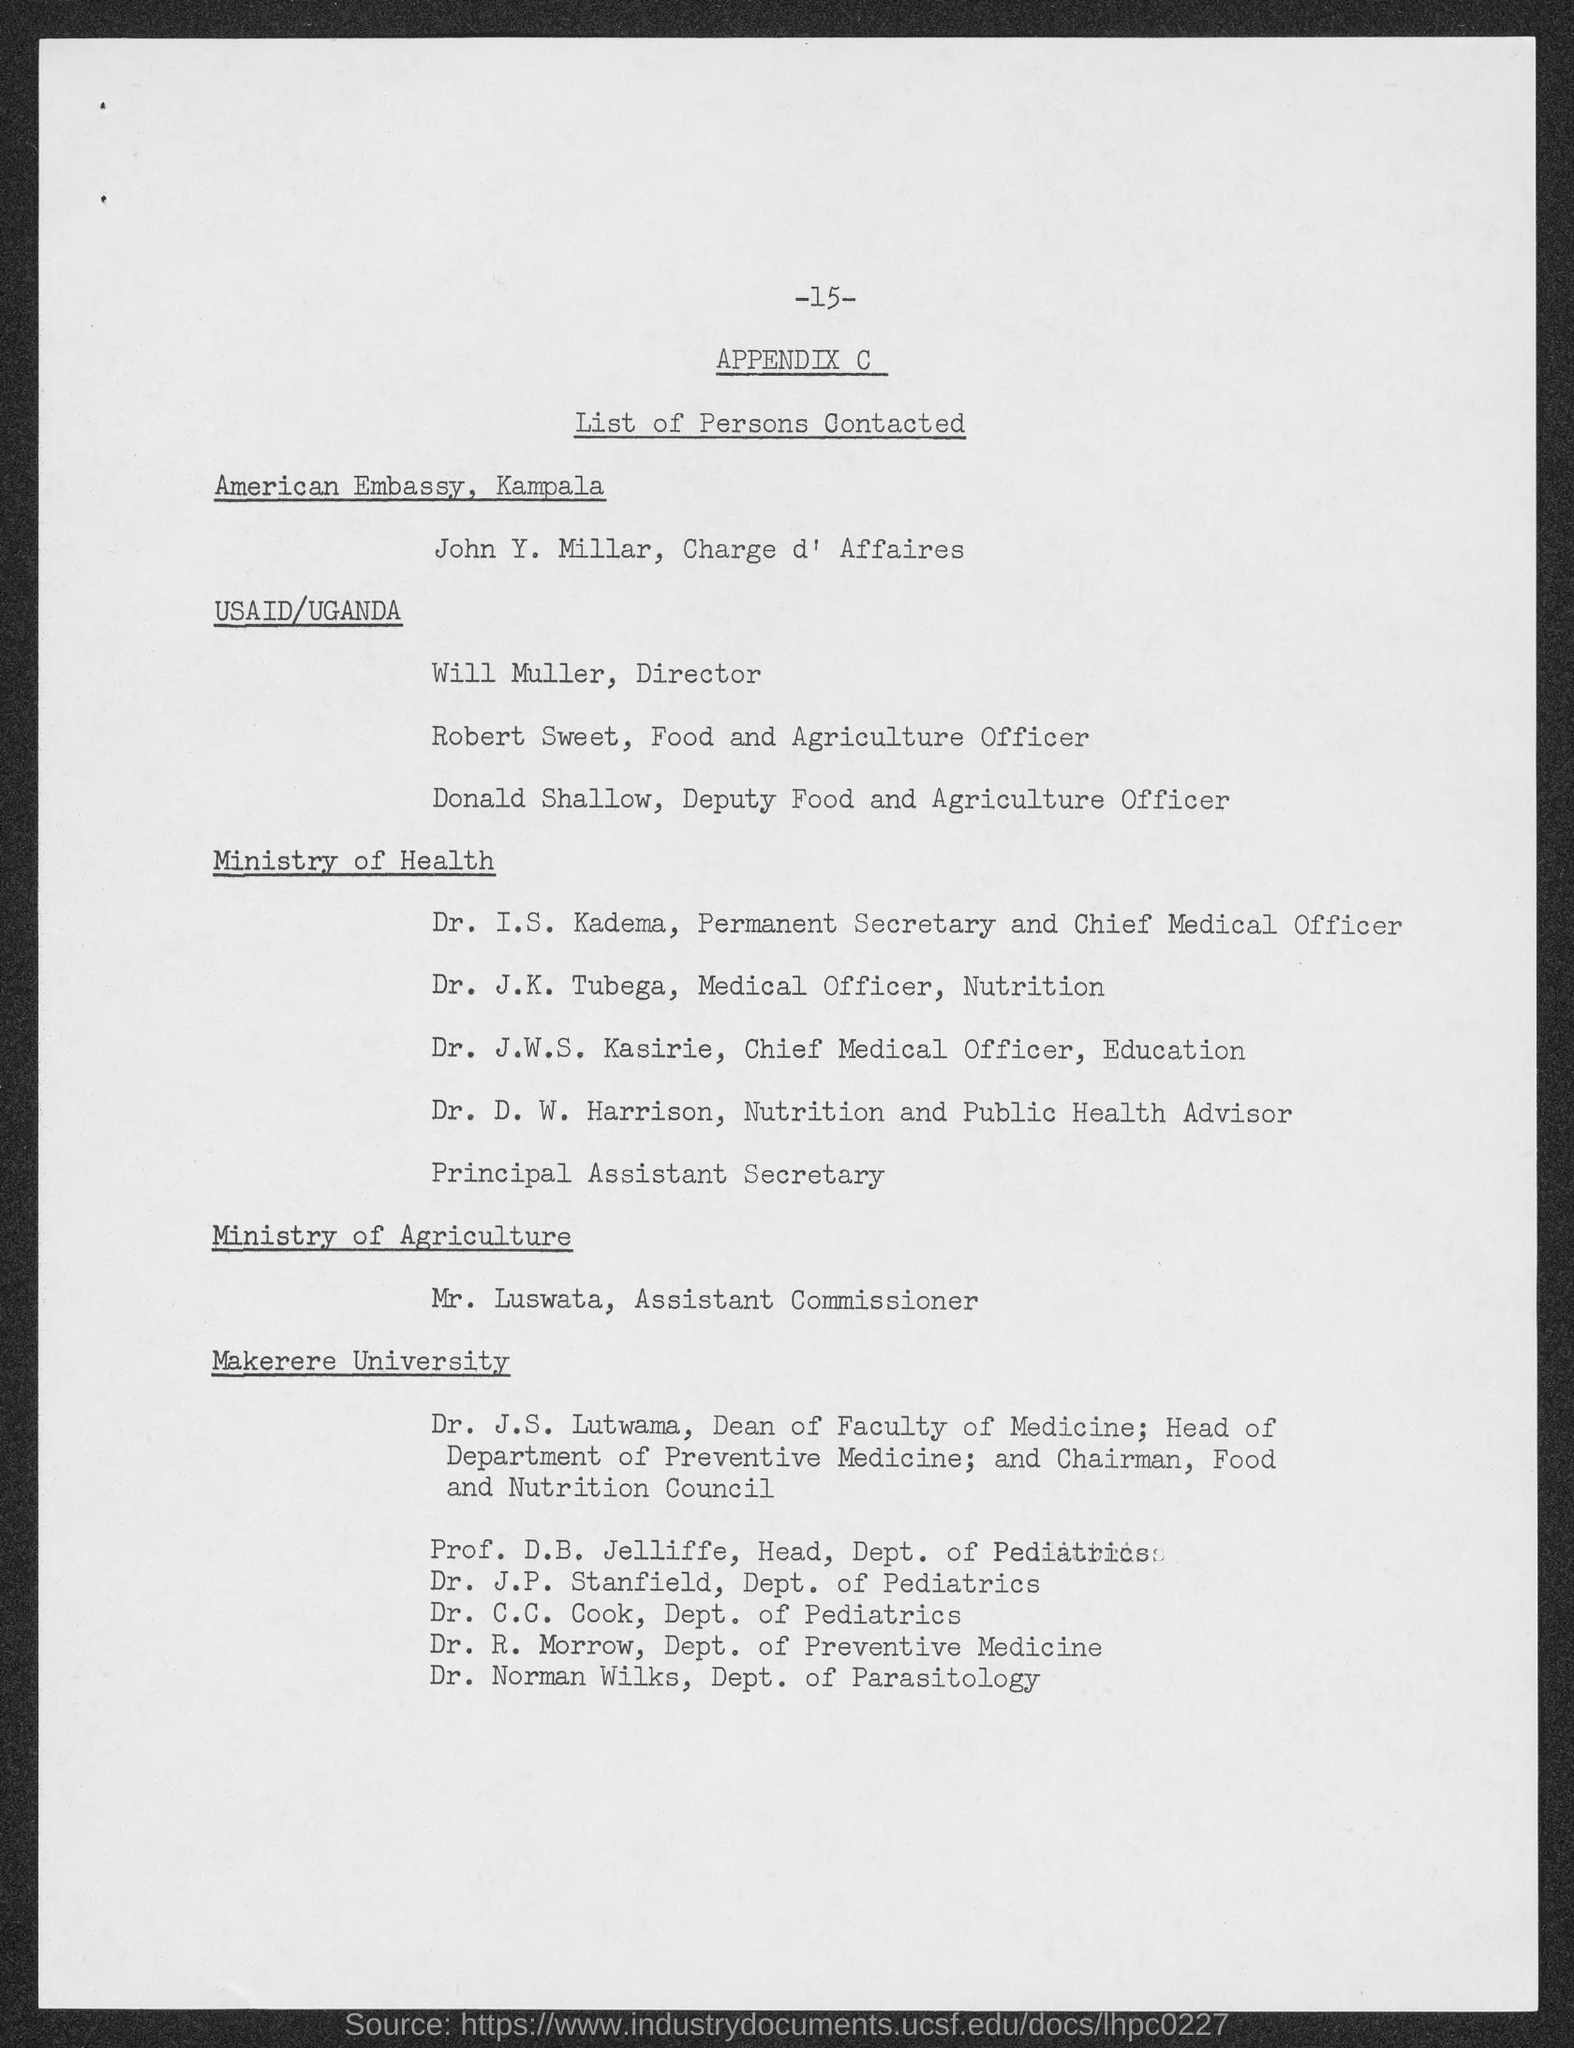What is the Page Number?
Give a very brief answer. -15-. Where is John Y. Millar from?
Make the answer very short. American Embassy, Kampala. Where is Will Muller from?
Make the answer very short. Usaid/uganda. Where is Robert Sweet from?
Offer a very short reply. USAID/UGANDA. Where is Donald Shallow from?
Offer a very short reply. USAID/UGANDA. Where is Dr. I.S. Kadema from?
Ensure brevity in your answer.  Ministry of Health. Where is Dr. J.K. Tubega from?
Your answer should be compact. Ministry of health. Where is Dr. J.W.S. Kasirie from?
Your answer should be compact. Ministry of Health. Where is Dr. D.W. Harrison from?
Ensure brevity in your answer.  Ministry of Health. Where is Mr. Luswata from?
Offer a very short reply. Ministry of agriculture. 